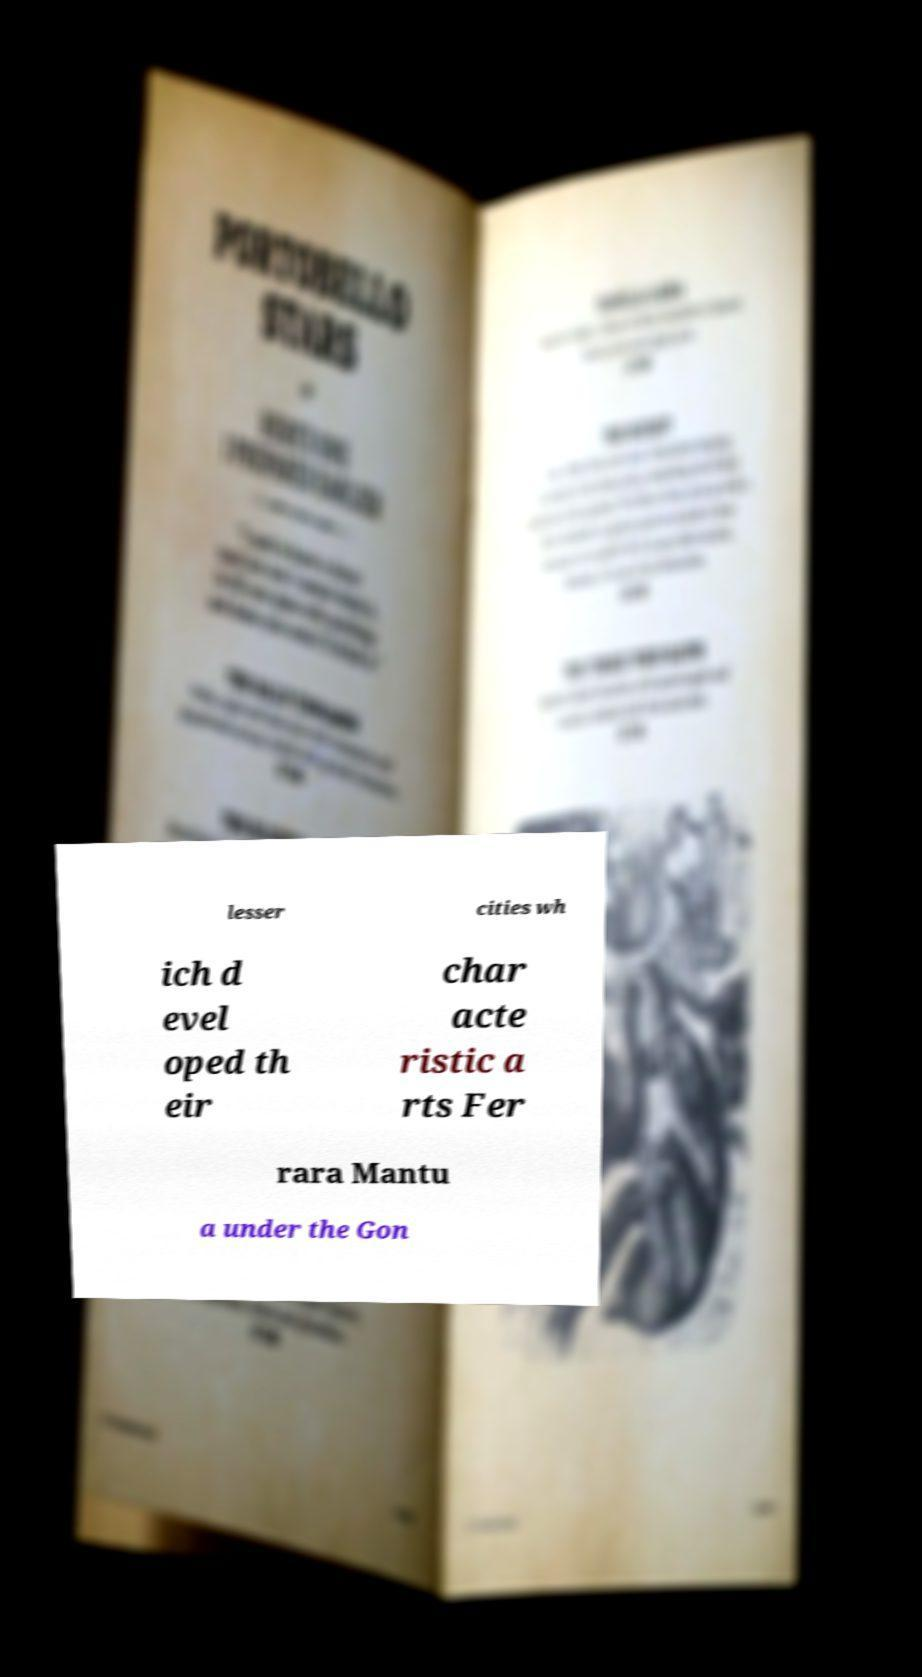Can you accurately transcribe the text from the provided image for me? lesser cities wh ich d evel oped th eir char acte ristic a rts Fer rara Mantu a under the Gon 